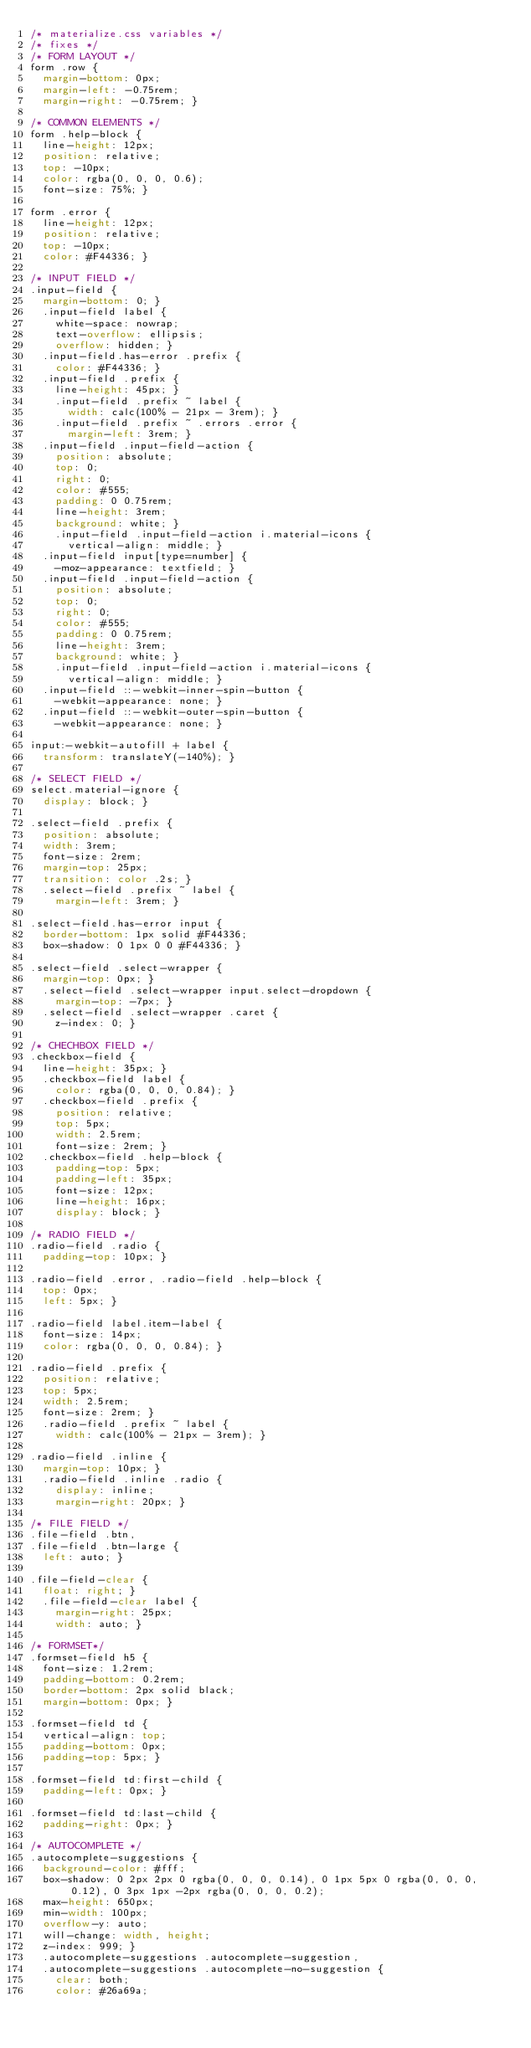<code> <loc_0><loc_0><loc_500><loc_500><_CSS_>/* materialize.css variables */
/* fixes */
/* FORM LAYOUT */
form .row {
  margin-bottom: 0px;
  margin-left: -0.75rem;
  margin-right: -0.75rem; }

/* COMMON ELEMENTS */
form .help-block {
  line-height: 12px;
  position: relative;
  top: -10px;
  color: rgba(0, 0, 0, 0.6);
  font-size: 75%; }

form .error {
  line-height: 12px;
  position: relative;
  top: -10px;
  color: #F44336; }

/* INPUT FIELD */
.input-field {
  margin-bottom: 0; }
  .input-field label {
    white-space: nowrap;
    text-overflow: ellipsis;
    overflow: hidden; }
  .input-field.has-error .prefix {
    color: #F44336; }
  .input-field .prefix {
    line-height: 45px; }
    .input-field .prefix ~ label {
      width: calc(100% - 21px - 3rem); }
    .input-field .prefix ~ .errors .error {
      margin-left: 3rem; }
  .input-field .input-field-action {
    position: absolute;
    top: 0;
    right: 0;
    color: #555;
    padding: 0 0.75rem;
    line-height: 3rem;
    background: white; }
    .input-field .input-field-action i.material-icons {
      vertical-align: middle; }
  .input-field input[type=number] {
    -moz-appearance: textfield; }
  .input-field .input-field-action {
    position: absolute;
    top: 0;
    right: 0;
    color: #555;
    padding: 0 0.75rem;
    line-height: 3rem;
    background: white; }
    .input-field .input-field-action i.material-icons {
      vertical-align: middle; }
  .input-field ::-webkit-inner-spin-button {
    -webkit-appearance: none; }
  .input-field ::-webkit-outer-spin-button {
    -webkit-appearance: none; }

input:-webkit-autofill + label {
  transform: translateY(-140%); }

/* SELECT FIELD */
select.material-ignore {
  display: block; }

.select-field .prefix {
  position: absolute;
  width: 3rem;
  font-size: 2rem;
  margin-top: 25px;
  transition: color .2s; }
  .select-field .prefix ~ label {
    margin-left: 3rem; }

.select-field.has-error input {
  border-bottom: 1px solid #F44336;
  box-shadow: 0 1px 0 0 #F44336; }

.select-field .select-wrapper {
  margin-top: 0px; }
  .select-field .select-wrapper input.select-dropdown {
    margin-top: -7px; }
  .select-field .select-wrapper .caret {
    z-index: 0; }

/* CHECHBOX FIELD */
.checkbox-field {
  line-height: 35px; }
  .checkbox-field label {
    color: rgba(0, 0, 0, 0.84); }
  .checkbox-field .prefix {
    position: relative;
    top: 5px;
    width: 2.5rem;
    font-size: 2rem; }
  .checkbox-field .help-block {
    padding-top: 5px;
    padding-left: 35px;
    font-size: 12px;
    line-height: 16px;
    display: block; }

/* RADIO FIELD */
.radio-field .radio {
  padding-top: 10px; }

.radio-field .error, .radio-field .help-block {
  top: 0px;
  left: 5px; }

.radio-field label.item-label {
  font-size: 14px;
  color: rgba(0, 0, 0, 0.84); }

.radio-field .prefix {
  position: relative;
  top: 5px;
  width: 2.5rem;
  font-size: 2rem; }
  .radio-field .prefix ~ label {
    width: calc(100% - 21px - 3rem); }

.radio-field .inline {
  margin-top: 10px; }
  .radio-field .inline .radio {
    display: inline;
    margin-right: 20px; }

/* FILE FIELD */
.file-field .btn,
.file-field .btn-large {
  left: auto; }

.file-field-clear {
  float: right; }
  .file-field-clear label {
    margin-right: 25px;
    width: auto; }

/* FORMSET*/
.formset-field h5 {
  font-size: 1.2rem;
  padding-bottom: 0.2rem;
  border-bottom: 2px solid black;
  margin-bottom: 0px; }

.formset-field td {
  vertical-align: top;
  padding-bottom: 0px;
  padding-top: 5px; }

.formset-field td:first-child {
  padding-left: 0px; }

.formset-field td:last-child {
  padding-right: 0px; }

/* AUTOCOMPLETE */
.autocomplete-suggestions {
  background-color: #fff;
  box-shadow: 0 2px 2px 0 rgba(0, 0, 0, 0.14), 0 1px 5px 0 rgba(0, 0, 0, 0.12), 0 3px 1px -2px rgba(0, 0, 0, 0.2);
  max-height: 650px;
  min-width: 100px;
  overflow-y: auto;
  will-change: width, height;
  z-index: 999; }
  .autocomplete-suggestions .autocomplete-suggestion,
  .autocomplete-suggestions .autocomplete-no-suggestion {
    clear: both;
    color: #26a69a;</code> 